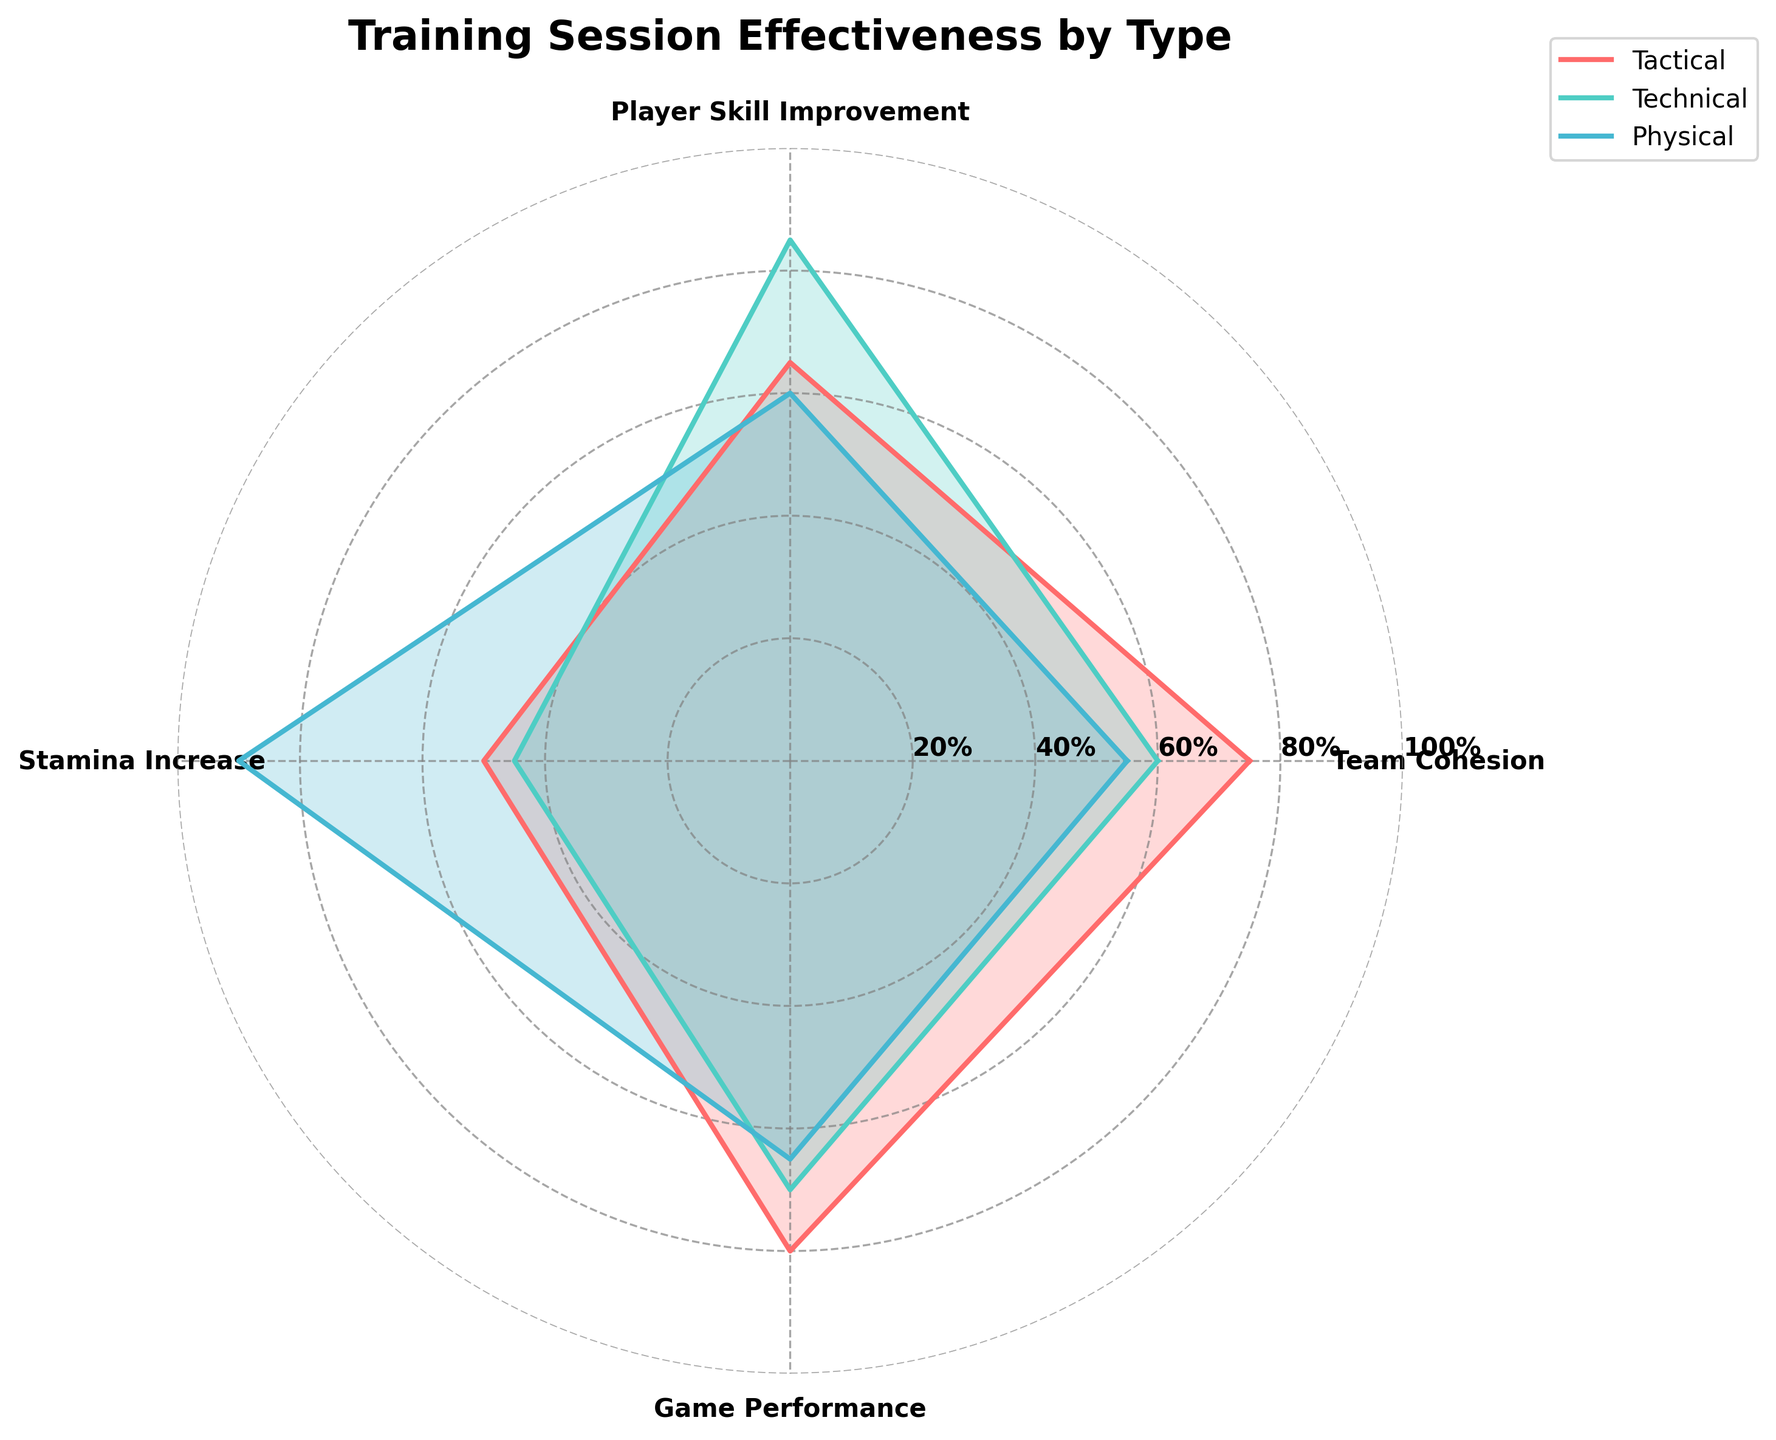What's the title of the radar chart? The title is usually at the top of the chart and gives a summary of the content. Here, the graph's title is clearly labeled on the top.
Answer: Training Session Effectiveness by Type How many training types are visualized on the radar chart? The radar chart showcases different training types by using distinct colors and labels for each. Counting these reveals the number of training types.
Answer: Three Which training type showed the highest score in Game Performance? By inspecting the "Game Performance" axis and looking at the highest point, the corresponding training type can be identified.
Answer: Tactical Which training type shows the lowest value in Player Skill Improvement? Check the "Player Skill Improvement" axis and identify the lowest value, then trace it back to the training type it represents.
Answer: Physical What's the difference in Stamina Increase between Physical and Technical training types? Find and subtract the "Stamina Increase" value of Technical (45) from Physical (90).
Answer: 45 On average, which training type scores highest in Team Cohesion and Game Performance combined? Add the scores of Team Cohesion and Game Performance for each training type, then calculate the averages and compare them. Tactical: (75 + 80) / 2 = 77.5, Technical: (60 + 70) / 2 = 65, Physical: (55 + 65) / 2 = 60. Since 77.5 is the highest average, Tactical is the answer.
Answer: Tactical Is the score for Physical training in Player Skill Improvement higher or lower than that for Technical training in the same category? Compare the "Player Skill Improvement" score for Physical (60) to Technical (85).
Answer: Lower In which category does Tactical training have nearly the same score as Technical training? Compare the five categories (Team Cohesion, Player Skill Improvement, Stamina Increase, Game Performance) to see where Tactical and Technical scores are closest.
Answer: Game Performance Which training type has the most consistent scores across all categories? Consider the range and variability of the scores for each training type. The lower the range, the more consistent the scores. Tactical: 80-50 = 30, Technical: 85-45 = 40, Physical: 90-55 = 35, making Tactical the most consistent.
Answer: Tactical 